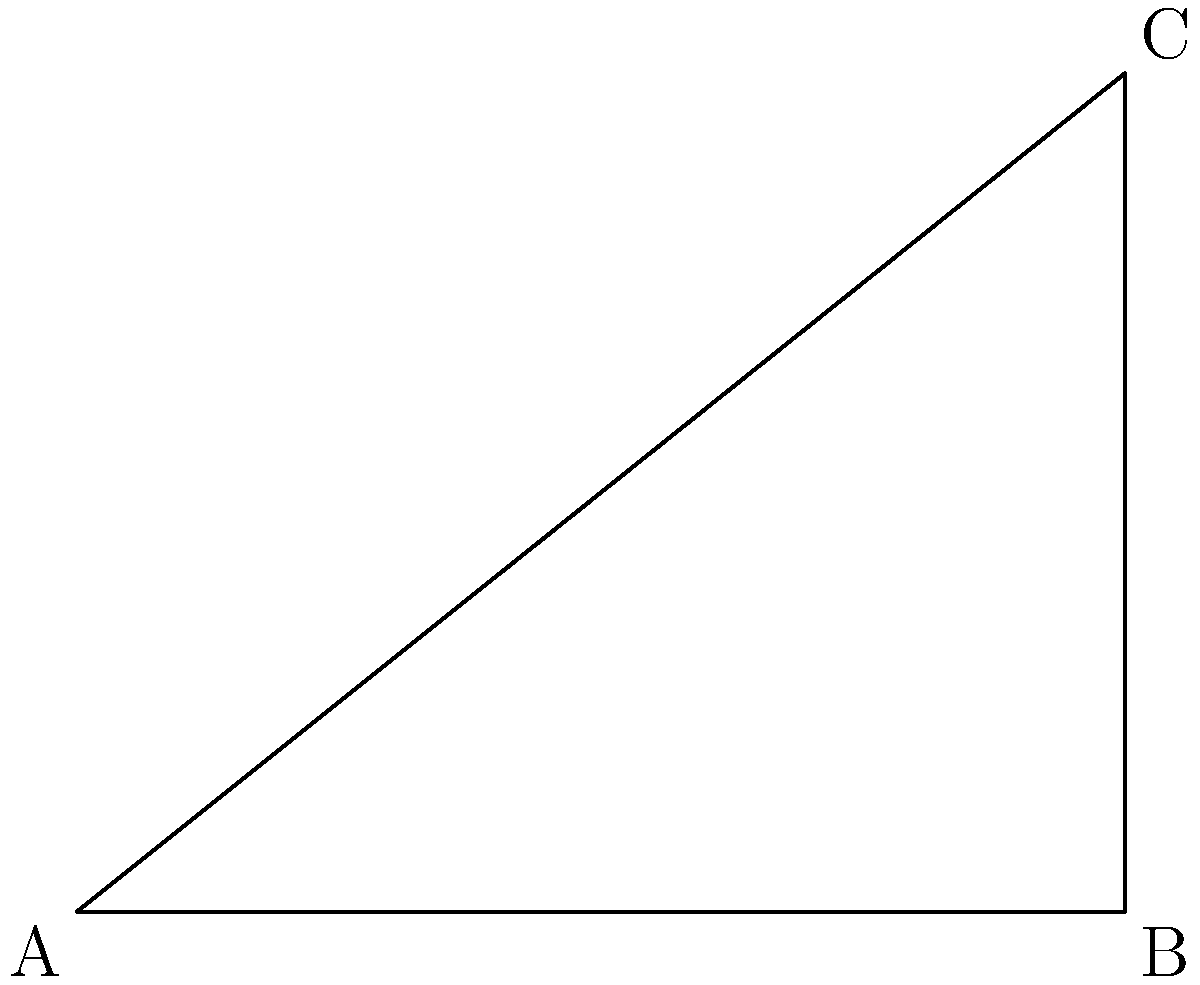During a fierce storm, a ship's mast is swaying dangerously. As an experienced seafarer, you need to calculate the angle of the mast relative to the horizon. The ship's deck is 100 meters long, and the top of the mast is currently 80 meters above the deck at its farthest point of sway. What is the angle $\theta$ between the mast and the horizon? To solve this problem, we can use trigonometry, specifically the arctangent function. Let's approach this step-by-step:

1. Identify the right triangle:
   - The deck forms the base (adjacent side) of 100 meters
   - The height of the mast forms the opposite side of 80 meters
   - The mast itself forms the hypotenuse
   - The angle we're looking for is between the base and the hypotenuse

2. We need to find the angle using the opposite and adjacent sides. This calls for the arctangent function:

   $$\theta = \arctan(\frac{\text{opposite}}{\text{adjacent}})$$

3. Plug in the values:

   $$\theta = \arctan(\frac{80}{100})$$

4. Simplify the fraction:

   $$\theta = \arctan(0.8)$$

5. Calculate the result:

   $$\theta \approx 38.66^\circ$$

6. Round to the nearest degree:

   $$\theta \approx 39^\circ$$

Thus, the angle between the mast and the horizon is approximately 39 degrees.
Answer: 39° 